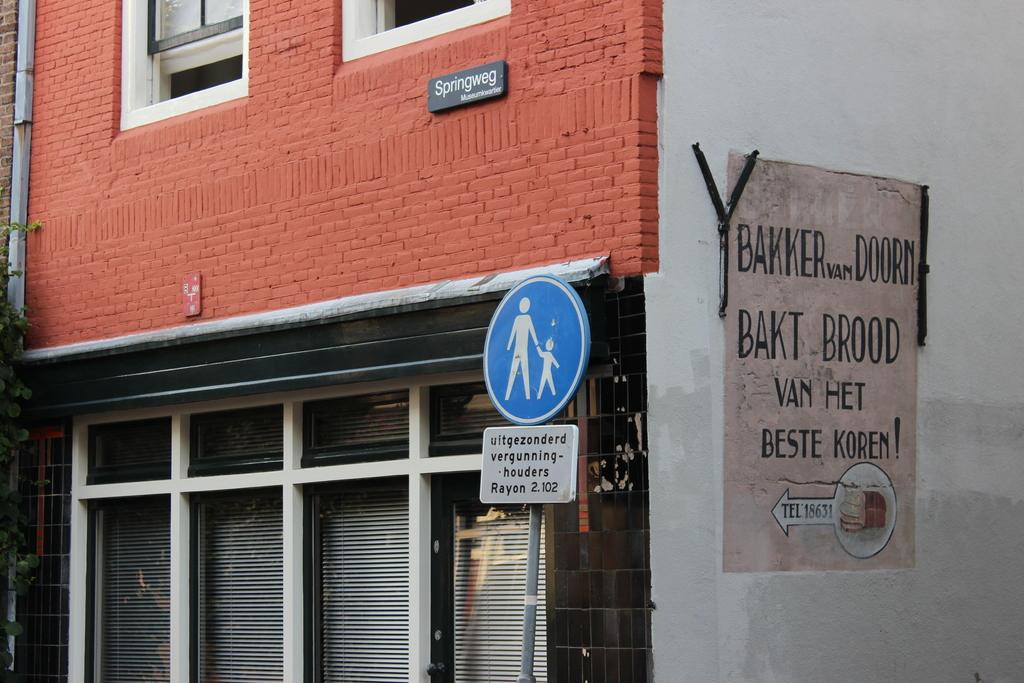What type of structure is visible in the image? There is a building in the image. What else can be seen in the image besides the building? There is a board and windows visible in the image. Can you tell if the image was taken during the day or night? The image was likely taken during the day, as there is no indication of darkness or artificial lighting. How many fire hydrants are visible in the image? There are no fire hydrants present in the image. What type of giants can be seen walking around the building in the image? There are no giants present in the image; it only features a building, a board, and windows. 